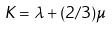Convert formula to latex. <formula><loc_0><loc_0><loc_500><loc_500>K = \lambda + ( 2 / 3 ) \mu</formula> 